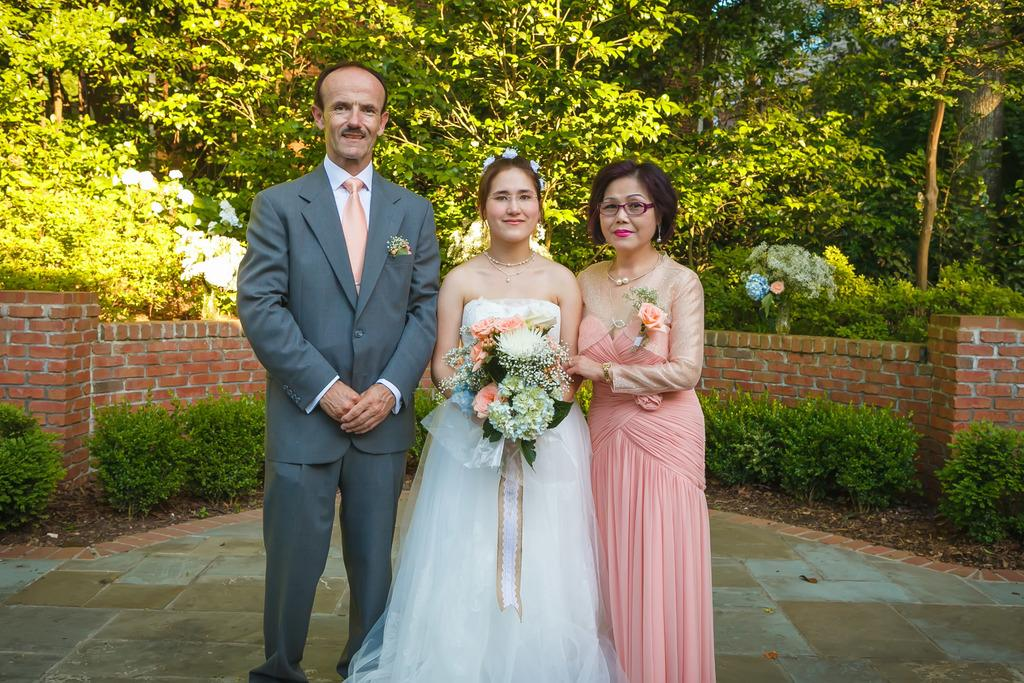What can be seen in the background of the image? There are many trees and plants in the background of the image. How many people are present in the image? There are three persons in the image. What type of hill can be seen in the image? There is no hill present in the image; it features trees and plants in the background. Can you tell me how the kettle is being used in the image? There is no kettle present in the image. 